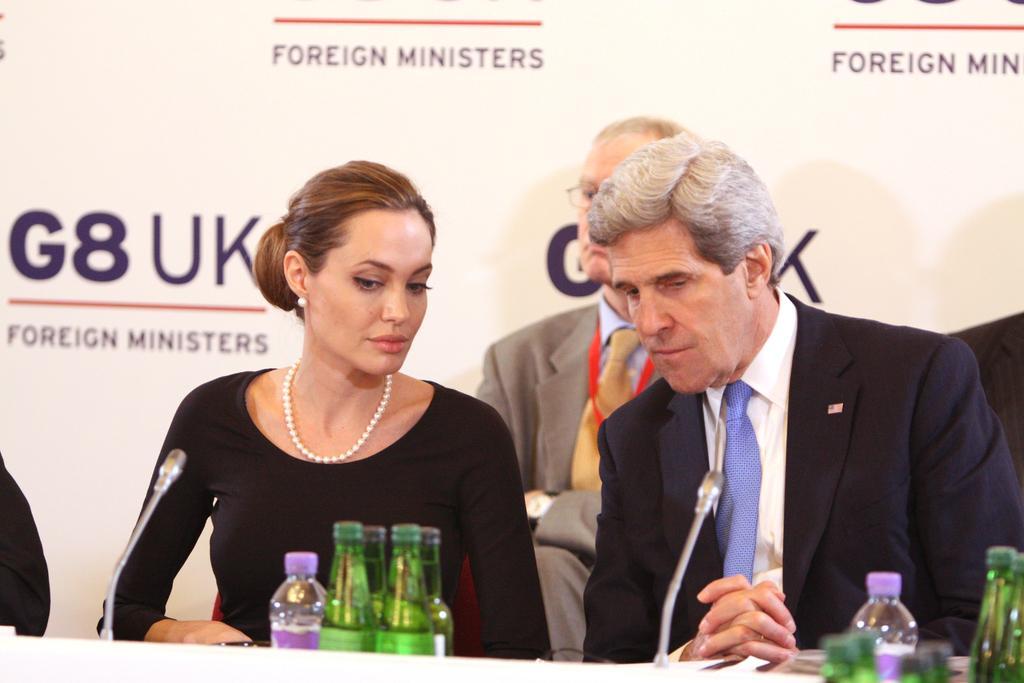How would you summarize this image in a sentence or two? In the picture I can see two men and a woman are sitting. The woman is wearing a necklace and two men are wearing suits. Here I can see bottles and microphones. In the background I can see a banner which has something written on it. 